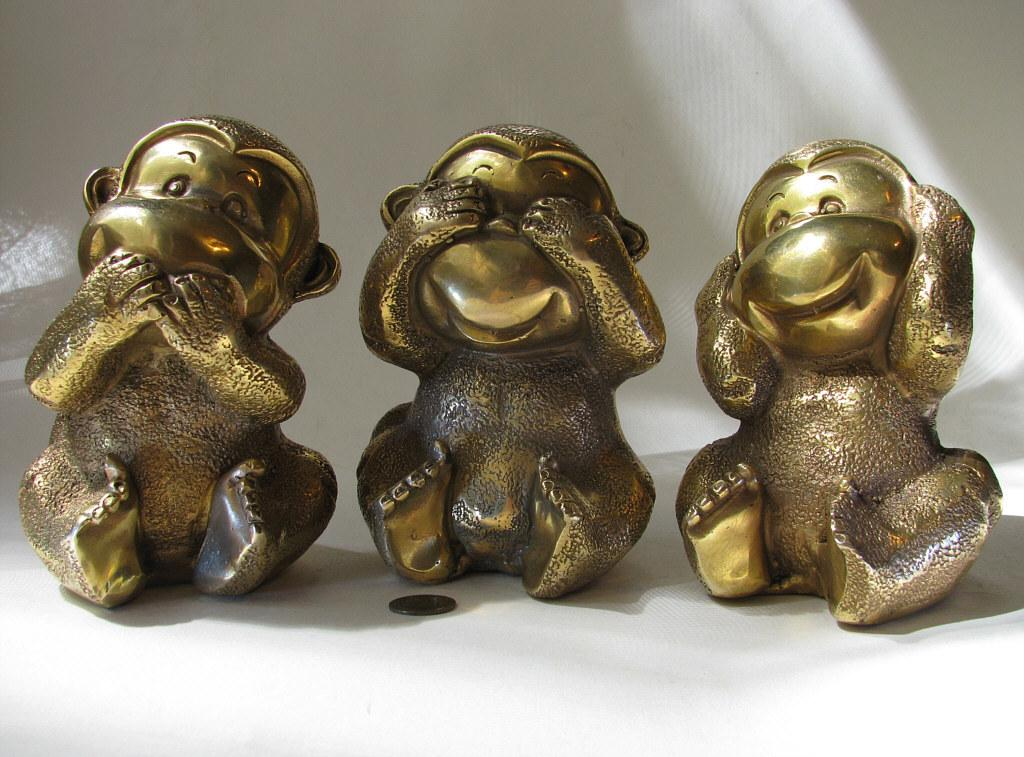What type of objects are depicted in the image? There are statues of three monkeys in the image. What are the statues made of? The statues are made of toys. Where are the statues placed? The statues are placed on a white table. What can be seen in the background of the image? There is a white wall in the background of the image. Are there any ladybugs crawling on the statues in the image? There are no ladybugs present in the image; it only features statues of three monkeys on a white table with a white wall in the background. 